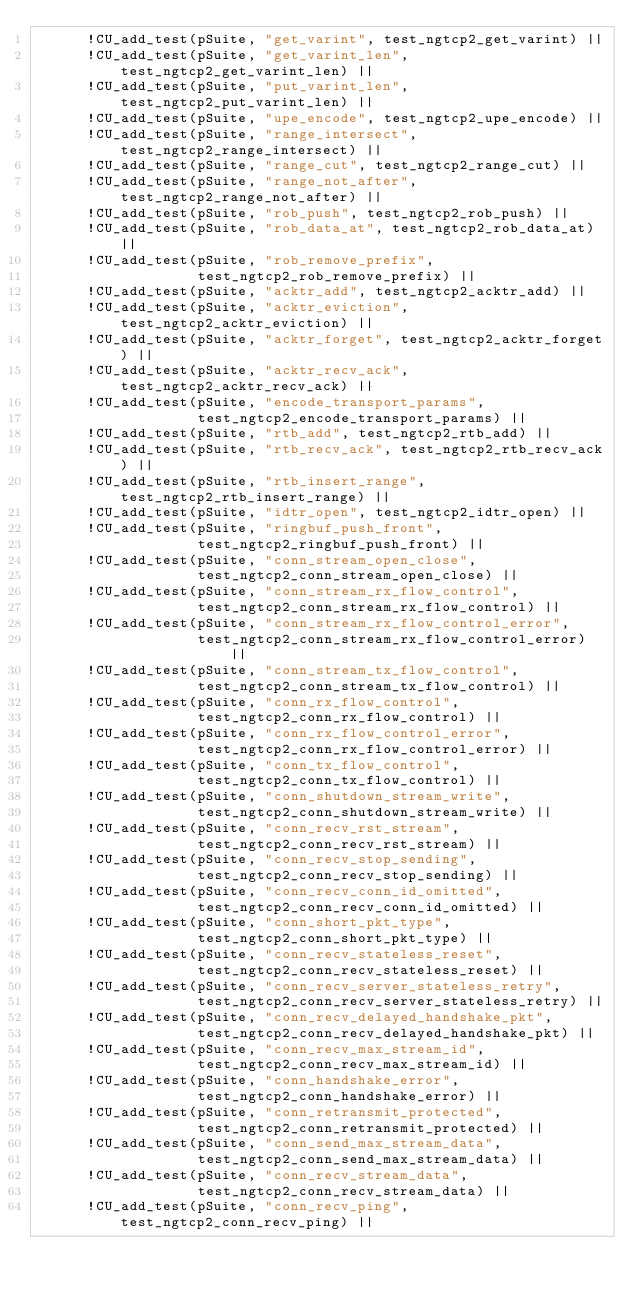<code> <loc_0><loc_0><loc_500><loc_500><_C_>      !CU_add_test(pSuite, "get_varint", test_ngtcp2_get_varint) ||
      !CU_add_test(pSuite, "get_varint_len", test_ngtcp2_get_varint_len) ||
      !CU_add_test(pSuite, "put_varint_len", test_ngtcp2_put_varint_len) ||
      !CU_add_test(pSuite, "upe_encode", test_ngtcp2_upe_encode) ||
      !CU_add_test(pSuite, "range_intersect", test_ngtcp2_range_intersect) ||
      !CU_add_test(pSuite, "range_cut", test_ngtcp2_range_cut) ||
      !CU_add_test(pSuite, "range_not_after", test_ngtcp2_range_not_after) ||
      !CU_add_test(pSuite, "rob_push", test_ngtcp2_rob_push) ||
      !CU_add_test(pSuite, "rob_data_at", test_ngtcp2_rob_data_at) ||
      !CU_add_test(pSuite, "rob_remove_prefix",
                   test_ngtcp2_rob_remove_prefix) ||
      !CU_add_test(pSuite, "acktr_add", test_ngtcp2_acktr_add) ||
      !CU_add_test(pSuite, "acktr_eviction", test_ngtcp2_acktr_eviction) ||
      !CU_add_test(pSuite, "acktr_forget", test_ngtcp2_acktr_forget) ||
      !CU_add_test(pSuite, "acktr_recv_ack", test_ngtcp2_acktr_recv_ack) ||
      !CU_add_test(pSuite, "encode_transport_params",
                   test_ngtcp2_encode_transport_params) ||
      !CU_add_test(pSuite, "rtb_add", test_ngtcp2_rtb_add) ||
      !CU_add_test(pSuite, "rtb_recv_ack", test_ngtcp2_rtb_recv_ack) ||
      !CU_add_test(pSuite, "rtb_insert_range", test_ngtcp2_rtb_insert_range) ||
      !CU_add_test(pSuite, "idtr_open", test_ngtcp2_idtr_open) ||
      !CU_add_test(pSuite, "ringbuf_push_front",
                   test_ngtcp2_ringbuf_push_front) ||
      !CU_add_test(pSuite, "conn_stream_open_close",
                   test_ngtcp2_conn_stream_open_close) ||
      !CU_add_test(pSuite, "conn_stream_rx_flow_control",
                   test_ngtcp2_conn_stream_rx_flow_control) ||
      !CU_add_test(pSuite, "conn_stream_rx_flow_control_error",
                   test_ngtcp2_conn_stream_rx_flow_control_error) ||
      !CU_add_test(pSuite, "conn_stream_tx_flow_control",
                   test_ngtcp2_conn_stream_tx_flow_control) ||
      !CU_add_test(pSuite, "conn_rx_flow_control",
                   test_ngtcp2_conn_rx_flow_control) ||
      !CU_add_test(pSuite, "conn_rx_flow_control_error",
                   test_ngtcp2_conn_rx_flow_control_error) ||
      !CU_add_test(pSuite, "conn_tx_flow_control",
                   test_ngtcp2_conn_tx_flow_control) ||
      !CU_add_test(pSuite, "conn_shutdown_stream_write",
                   test_ngtcp2_conn_shutdown_stream_write) ||
      !CU_add_test(pSuite, "conn_recv_rst_stream",
                   test_ngtcp2_conn_recv_rst_stream) ||
      !CU_add_test(pSuite, "conn_recv_stop_sending",
                   test_ngtcp2_conn_recv_stop_sending) ||
      !CU_add_test(pSuite, "conn_recv_conn_id_omitted",
                   test_ngtcp2_conn_recv_conn_id_omitted) ||
      !CU_add_test(pSuite, "conn_short_pkt_type",
                   test_ngtcp2_conn_short_pkt_type) ||
      !CU_add_test(pSuite, "conn_recv_stateless_reset",
                   test_ngtcp2_conn_recv_stateless_reset) ||
      !CU_add_test(pSuite, "conn_recv_server_stateless_retry",
                   test_ngtcp2_conn_recv_server_stateless_retry) ||
      !CU_add_test(pSuite, "conn_recv_delayed_handshake_pkt",
                   test_ngtcp2_conn_recv_delayed_handshake_pkt) ||
      !CU_add_test(pSuite, "conn_recv_max_stream_id",
                   test_ngtcp2_conn_recv_max_stream_id) ||
      !CU_add_test(pSuite, "conn_handshake_error",
                   test_ngtcp2_conn_handshake_error) ||
      !CU_add_test(pSuite, "conn_retransmit_protected",
                   test_ngtcp2_conn_retransmit_protected) ||
      !CU_add_test(pSuite, "conn_send_max_stream_data",
                   test_ngtcp2_conn_send_max_stream_data) ||
      !CU_add_test(pSuite, "conn_recv_stream_data",
                   test_ngtcp2_conn_recv_stream_data) ||
      !CU_add_test(pSuite, "conn_recv_ping", test_ngtcp2_conn_recv_ping) ||</code> 